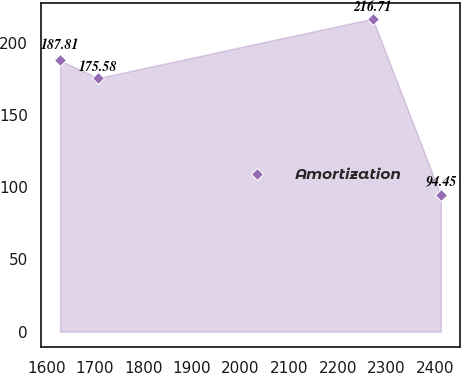Convert chart. <chart><loc_0><loc_0><loc_500><loc_500><line_chart><ecel><fcel>Amortization<nl><fcel>1628.07<fcel>187.81<nl><fcel>1706.5<fcel>175.58<nl><fcel>2272.04<fcel>216.71<nl><fcel>2412.41<fcel>94.45<nl></chart> 